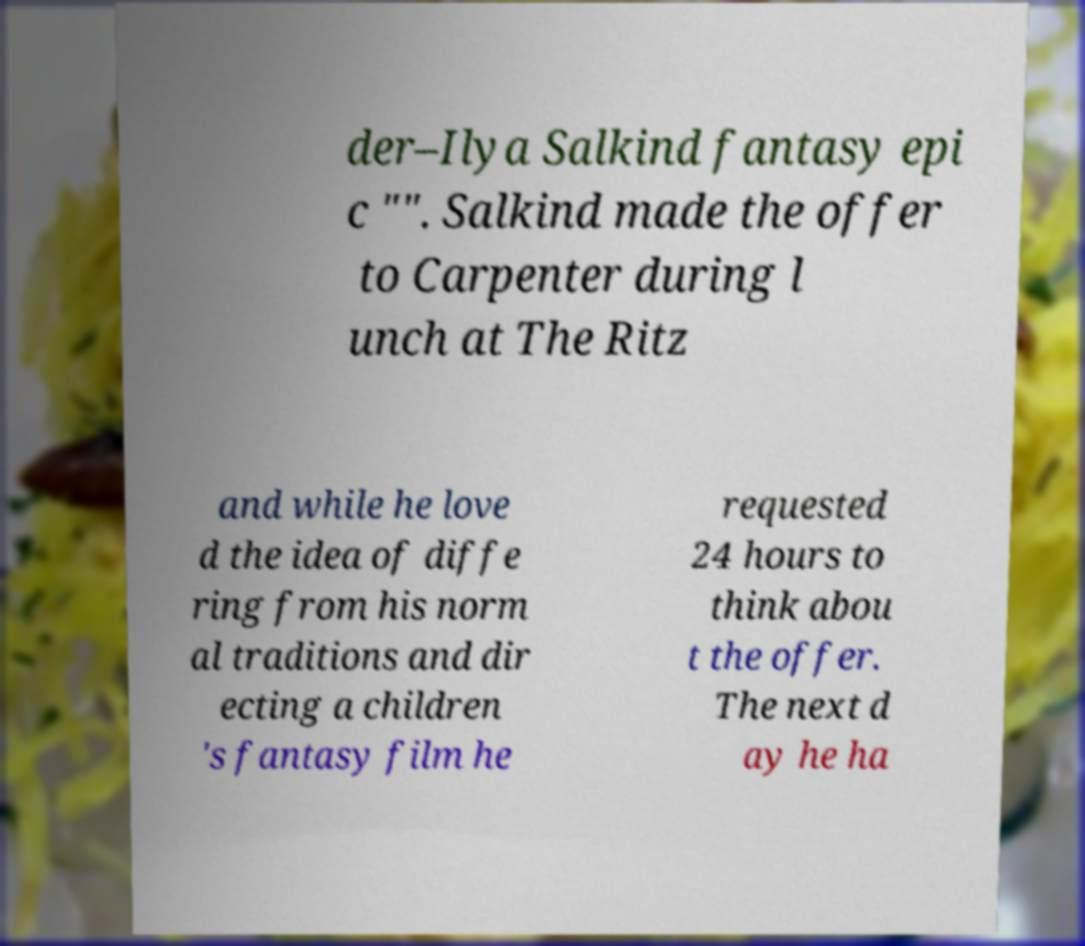Could you extract and type out the text from this image? der–Ilya Salkind fantasy epi c "". Salkind made the offer to Carpenter during l unch at The Ritz and while he love d the idea of diffe ring from his norm al traditions and dir ecting a children 's fantasy film he requested 24 hours to think abou t the offer. The next d ay he ha 